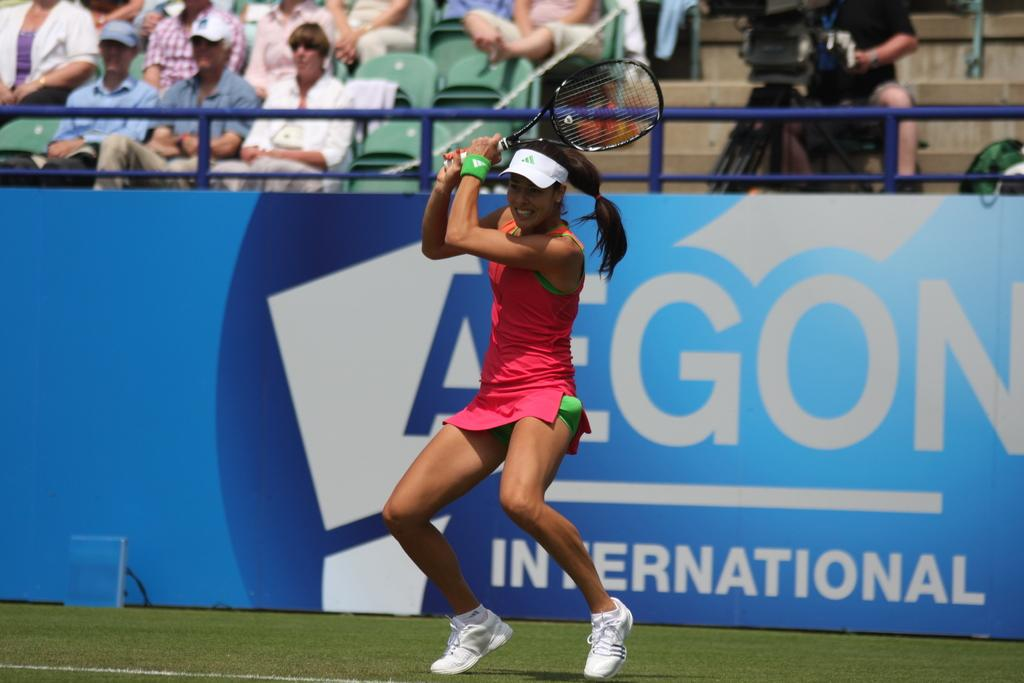What is the woman in the image holding? The woman is holding a bat in the image. What can be seen in the background of the image? There is a crowd sitting on chairs in the image. What else is present in the image besides the woman and the crowd? The image contains a poster. What type of wood is the woman using to smell her nose in the image? There is no wood or any action related to smelling in the image. 